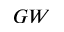<formula> <loc_0><loc_0><loc_500><loc_500>G W</formula> 